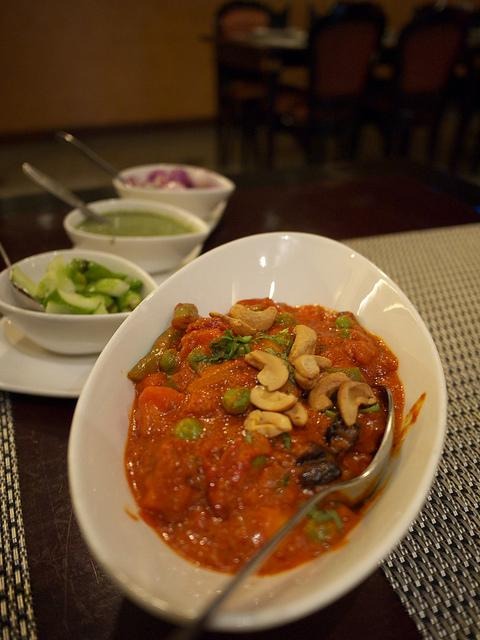What fungal growth is visible here? mushrooms 